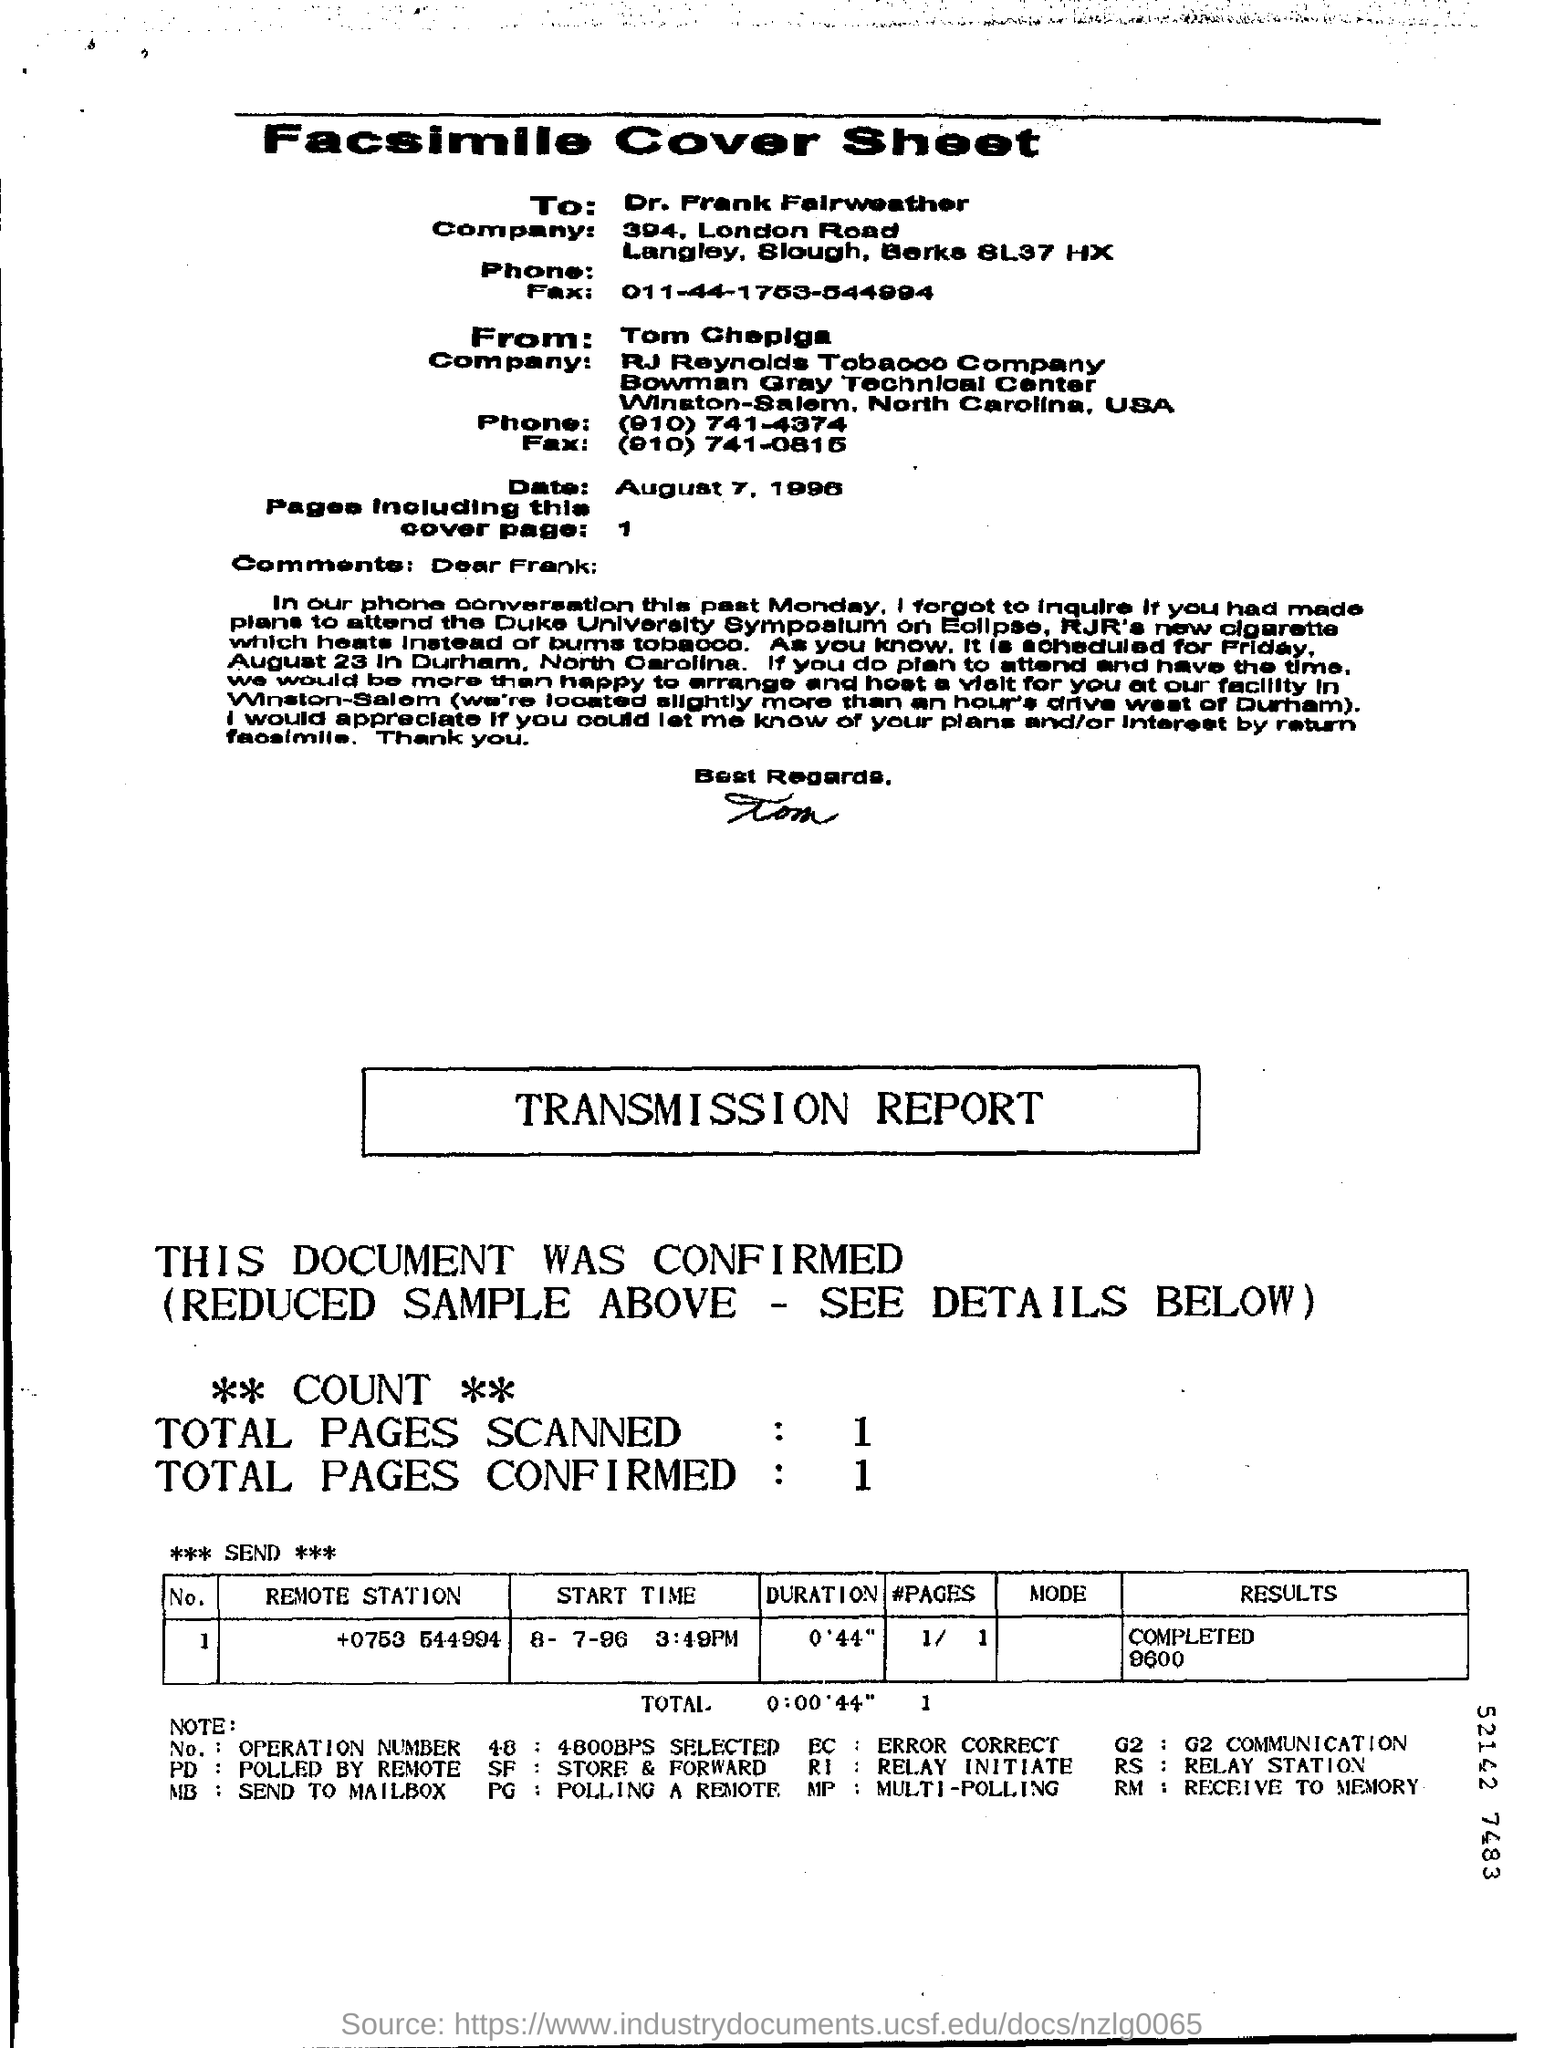Give some essential details in this illustration. The fax is directed to Dr. Frank Fairweather. The fax is addressed from Tom Chepiga. On August 7, 1996, the date is known. The results for the remote station with the phone number +0753 544994 have been completed, and the result is 9600. What is the duration for the remote station numbered +0753 544994? It is 0 minutes and 44 seconds. 